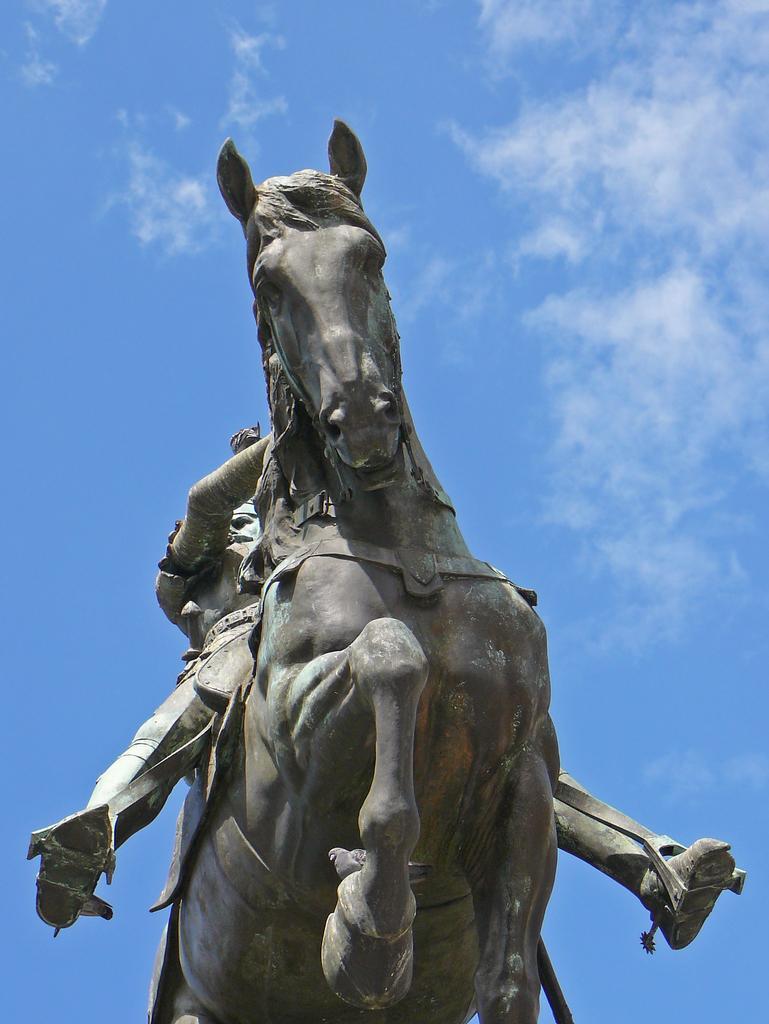Describe this image in one or two sentences. In this image we can see a sculpture of a person and a horse. Behind the sculpture, we can see the clear sky. 